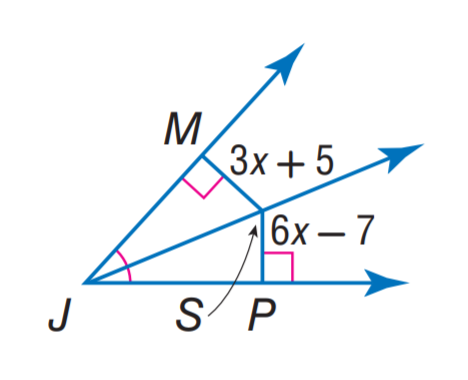Answer the mathemtical geometry problem and directly provide the correct option letter.
Question: Find S P.
Choices: A: 5 B: 6 C: 7 D: 17 D 